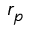Convert formula to latex. <formula><loc_0><loc_0><loc_500><loc_500>r _ { p }</formula> 